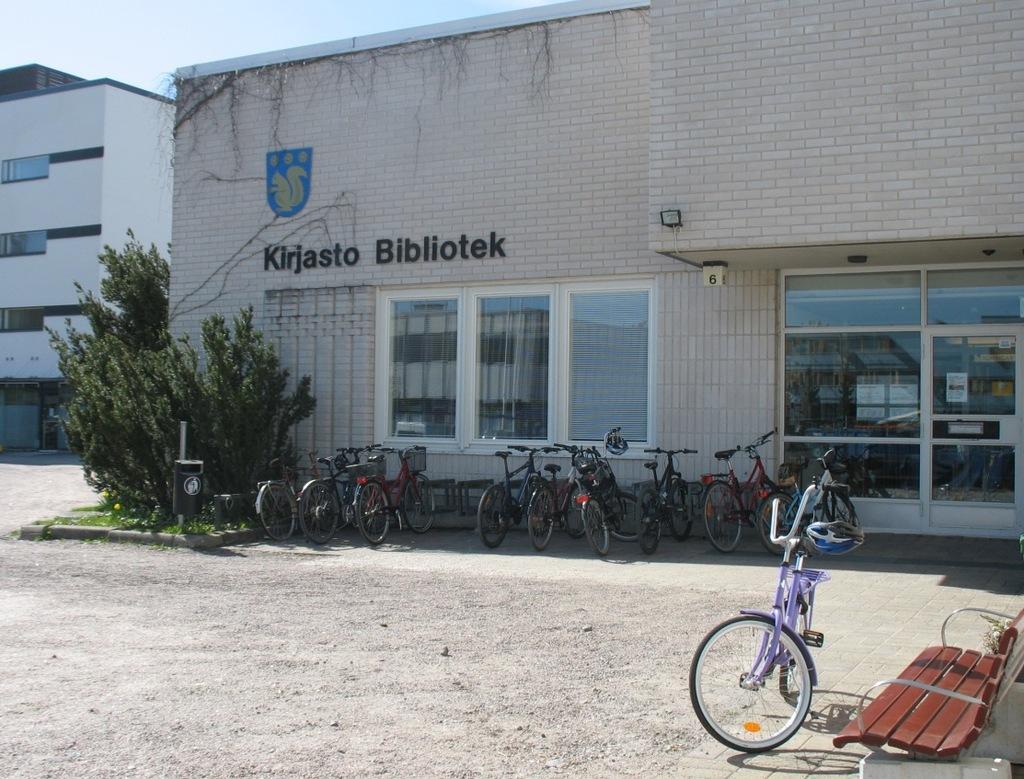Could you give a brief overview of what you see in this image? In this image there are buildings and trees. We can see bicycles. On the right there is a bench. In the background there is sky. 